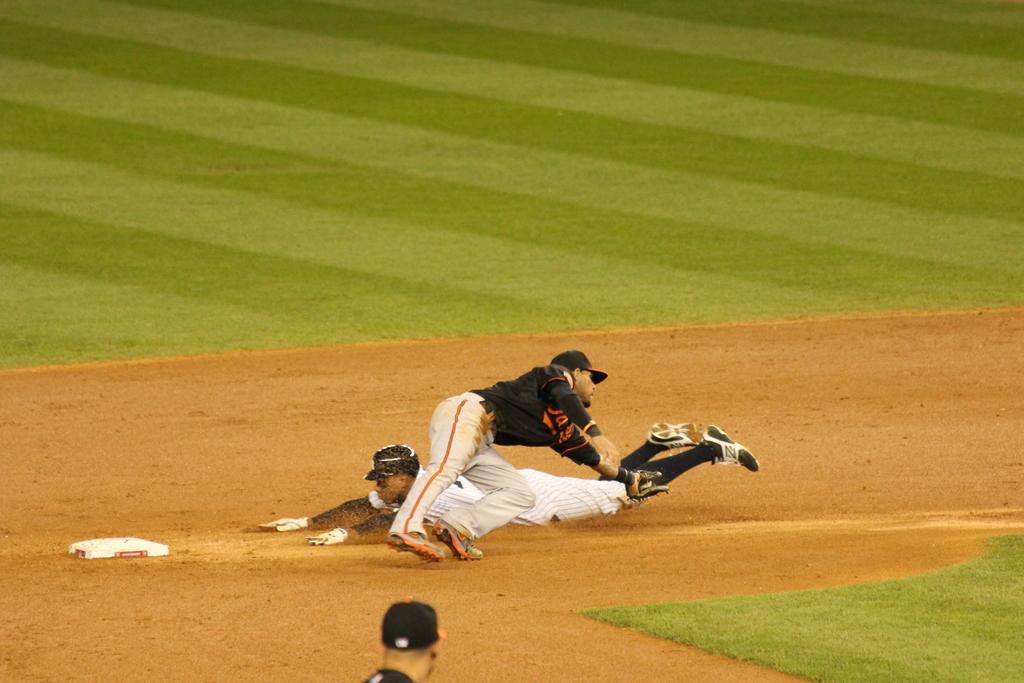In one or two sentences, can you explain what this image depicts? In this picture there are people and we can see white object on the ground and grass. 